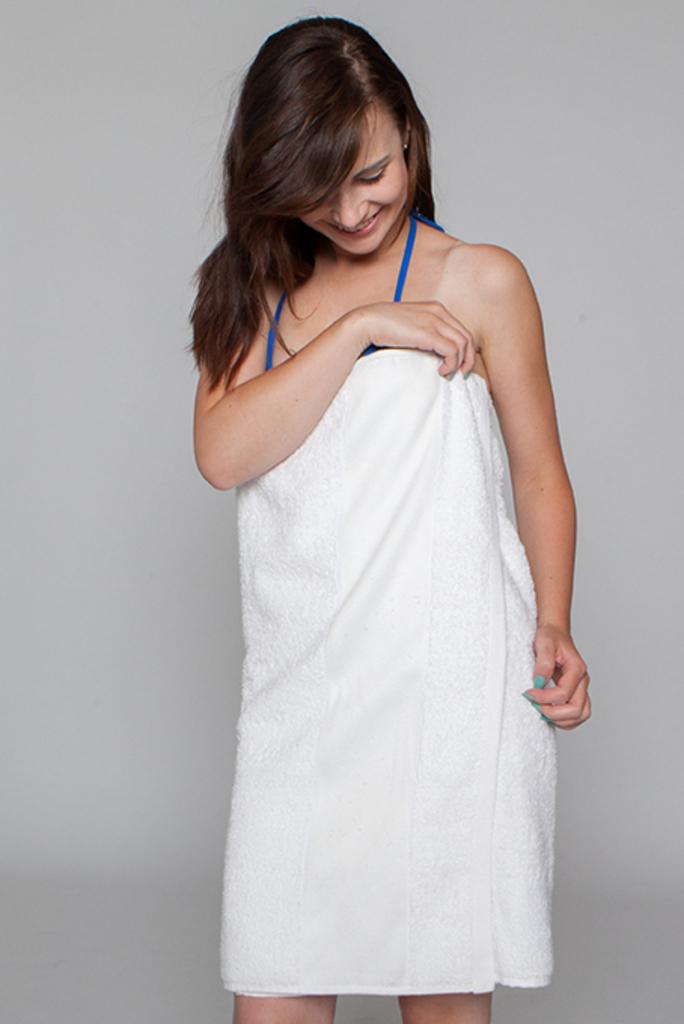Who is the main subject in the image? There is a woman in the image. How is the woman's hair styled? The woman has loose hair. What is the woman wearing in the image? The woman is wrapped in a white cloth. What is the woman doing with the cloth? The woman is holding the cloth. What is the woman's facial expression? The woman is smiling. What direction is the woman looking in? The woman is looking down. What type of suit is the woman wearing in the image? There is no suit present in the image; the woman is wrapped in a white cloth. 